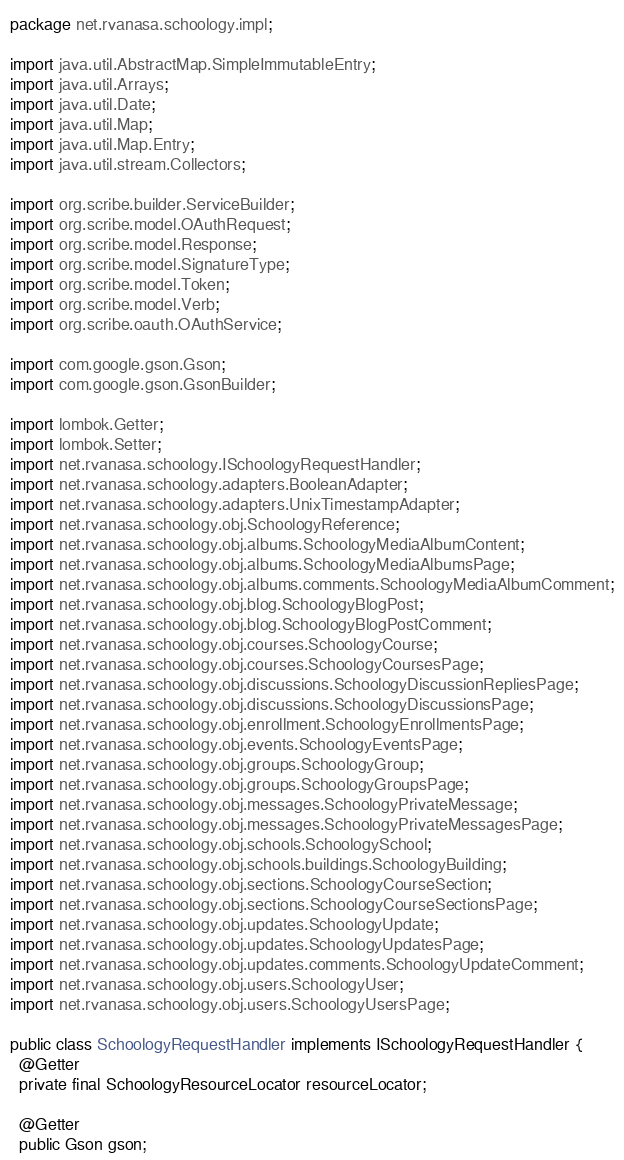<code> <loc_0><loc_0><loc_500><loc_500><_Java_>package net.rvanasa.schoology.impl;

import java.util.AbstractMap.SimpleImmutableEntry;
import java.util.Arrays;
import java.util.Date;
import java.util.Map;
import java.util.Map.Entry;
import java.util.stream.Collectors;

import org.scribe.builder.ServiceBuilder;
import org.scribe.model.OAuthRequest;
import org.scribe.model.Response;
import org.scribe.model.SignatureType;
import org.scribe.model.Token;
import org.scribe.model.Verb;
import org.scribe.oauth.OAuthService;

import com.google.gson.Gson;
import com.google.gson.GsonBuilder;

import lombok.Getter;
import lombok.Setter;
import net.rvanasa.schoology.ISchoologyRequestHandler;
import net.rvanasa.schoology.adapters.BooleanAdapter;
import net.rvanasa.schoology.adapters.UnixTimestampAdapter;
import net.rvanasa.schoology.obj.SchoologyReference;
import net.rvanasa.schoology.obj.albums.SchoologyMediaAlbumContent;
import net.rvanasa.schoology.obj.albums.SchoologyMediaAlbumsPage;
import net.rvanasa.schoology.obj.albums.comments.SchoologyMediaAlbumComment;
import net.rvanasa.schoology.obj.blog.SchoologyBlogPost;
import net.rvanasa.schoology.obj.blog.SchoologyBlogPostComment;
import net.rvanasa.schoology.obj.courses.SchoologyCourse;
import net.rvanasa.schoology.obj.courses.SchoologyCoursesPage;
import net.rvanasa.schoology.obj.discussions.SchoologyDiscussionRepliesPage;
import net.rvanasa.schoology.obj.discussions.SchoologyDiscussionsPage;
import net.rvanasa.schoology.obj.enrollment.SchoologyEnrollmentsPage;
import net.rvanasa.schoology.obj.events.SchoologyEventsPage;
import net.rvanasa.schoology.obj.groups.SchoologyGroup;
import net.rvanasa.schoology.obj.groups.SchoologyGroupsPage;
import net.rvanasa.schoology.obj.messages.SchoologyPrivateMessage;
import net.rvanasa.schoology.obj.messages.SchoologyPrivateMessagesPage;
import net.rvanasa.schoology.obj.schools.SchoologySchool;
import net.rvanasa.schoology.obj.schools.buildings.SchoologyBuilding;
import net.rvanasa.schoology.obj.sections.SchoologyCourseSection;
import net.rvanasa.schoology.obj.sections.SchoologyCourseSectionsPage;
import net.rvanasa.schoology.obj.updates.SchoologyUpdate;
import net.rvanasa.schoology.obj.updates.SchoologyUpdatesPage;
import net.rvanasa.schoology.obj.updates.comments.SchoologyUpdateComment;
import net.rvanasa.schoology.obj.users.SchoologyUser;
import net.rvanasa.schoology.obj.users.SchoologyUsersPage;

public class SchoologyRequestHandler implements ISchoologyRequestHandler {
  @Getter
  private final SchoologyResourceLocator resourceLocator;

  @Getter
  public Gson gson;
</code> 